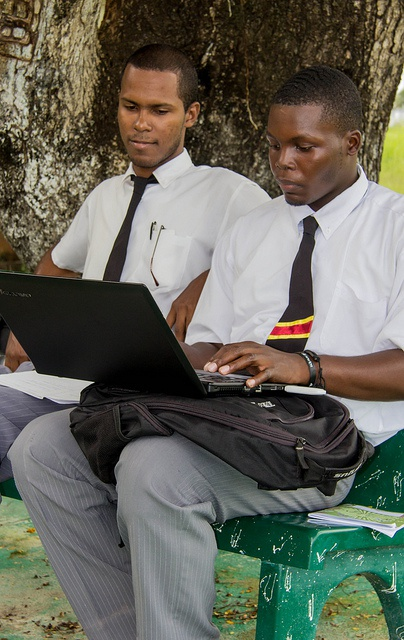Describe the objects in this image and their specific colors. I can see people in olive, black, gray, lightgray, and darkgray tones, people in olive, lightgray, darkgray, black, and gray tones, backpack in olive, black, and gray tones, bench in olive, darkgreen, and teal tones, and laptop in olive, black, gray, and darkgray tones in this image. 